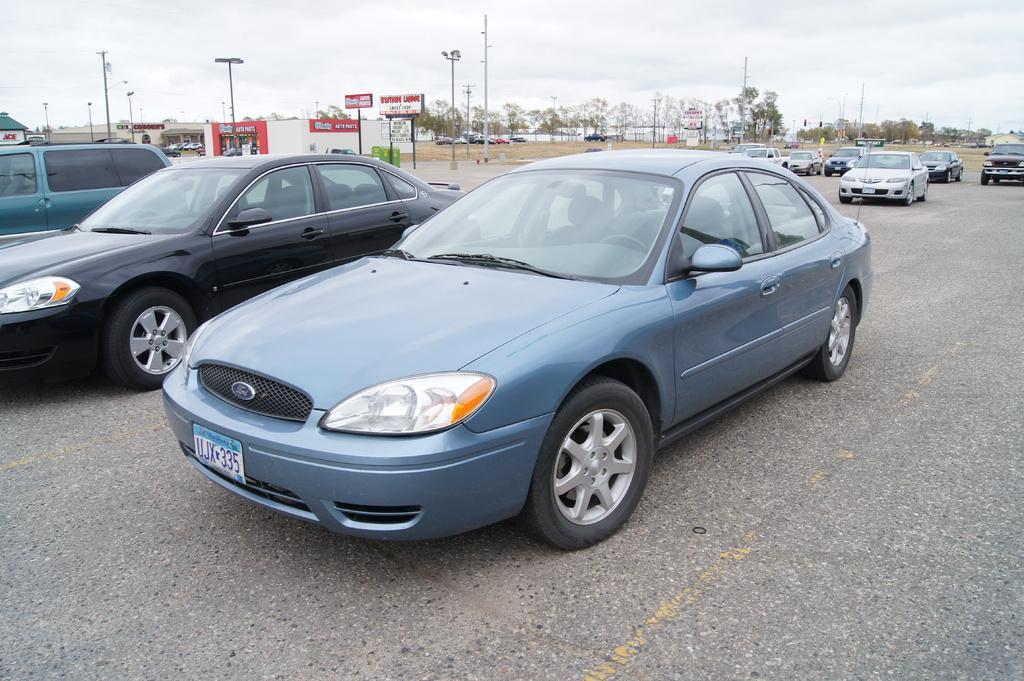Could you give a brief overview of what you see in this image? There are vehicles on the road. In the background, there are hoardings, near a building, there are vehicles parked on the ground, there are poles, trees and clouds in the sky. 